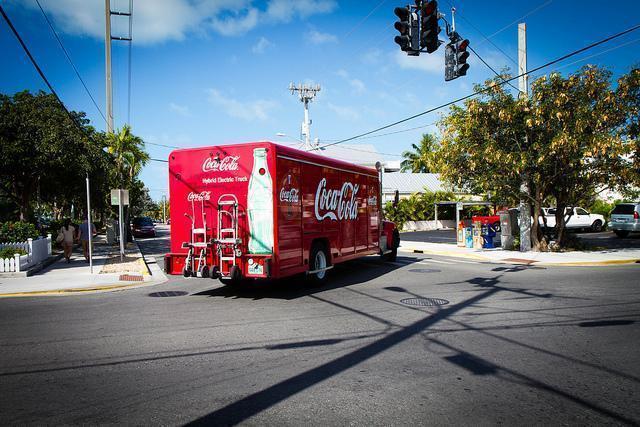Where is the truck going?
From the following set of four choices, select the accurate answer to respond to the question.
Options: Store, bank, beach, restaurant. Store. Why is the truck in the middle of the street?
Choose the correct response and explain in the format: 'Answer: answer
Rationale: rationale.'
Options: Parking, turning left, no gas, broken down. Answer: turning left.
Rationale: The truck is making a very wide turn because it is a larger vehicle. 